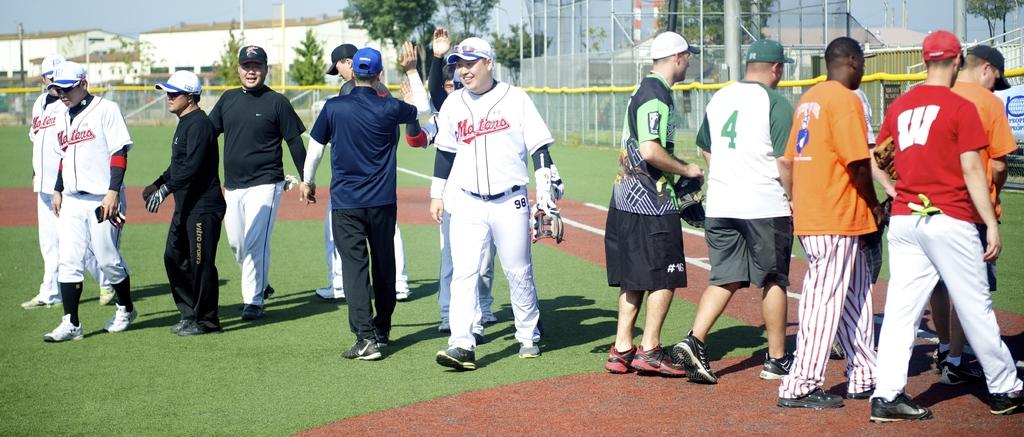What is the team name on the jersey?
Provide a succinct answer. Maters. 